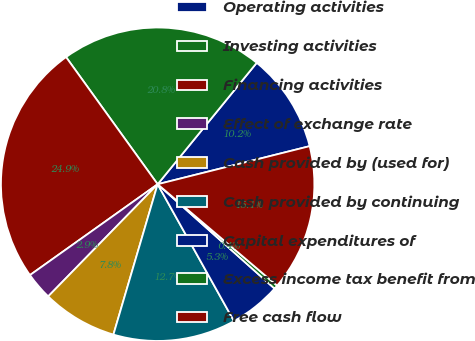Convert chart. <chart><loc_0><loc_0><loc_500><loc_500><pie_chart><fcel>Operating activities<fcel>Investing activities<fcel>Financing activities<fcel>Effect of exchange rate<fcel>Cash provided by (used for)<fcel>Cash provided by continuing<fcel>Capital expenditures of<fcel>Excess income tax benefit from<fcel>Free cash flow<nl><fcel>10.2%<fcel>20.82%<fcel>24.9%<fcel>2.85%<fcel>7.75%<fcel>12.65%<fcel>5.3%<fcel>0.4%<fcel>15.1%<nl></chart> 